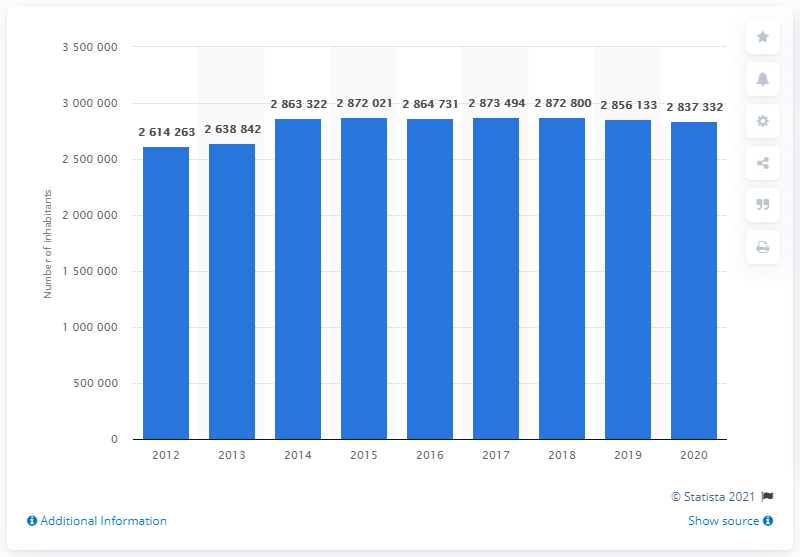How many people lived in Rome in 2012?
 2614263 